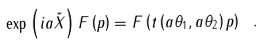Convert formula to latex. <formula><loc_0><loc_0><loc_500><loc_500>\exp \left ( i a \tilde { X } \right ) F \left ( p \right ) = F \left ( t \left ( a \theta _ { 1 } , a \theta _ { 2 } \right ) p \right ) \ .</formula> 